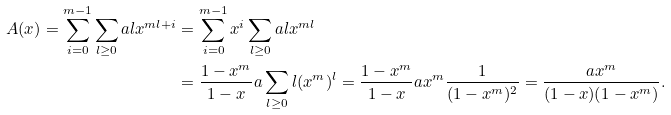<formula> <loc_0><loc_0><loc_500><loc_500>A ( x ) = \sum _ { i = 0 } ^ { m - 1 } \sum _ { l \geq 0 } a l x ^ { m l + i } & = \sum _ { i = 0 } ^ { m - 1 } x ^ { i } \sum _ { l \geq 0 } a l x ^ { m l } \\ & = \frac { 1 - x ^ { m } } { 1 - x } a \sum _ { l \geq 0 } l ( x ^ { m } ) ^ { l } = \frac { 1 - x ^ { m } } { 1 - x } a x ^ { m } \frac { 1 } { ( 1 - x ^ { m } ) ^ { 2 } } = \frac { a x ^ { m } } { ( 1 - x ) ( 1 - x ^ { m } ) } .</formula> 